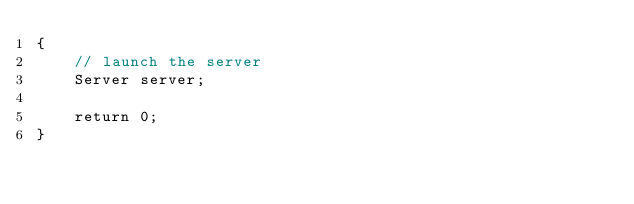<code> <loc_0><loc_0><loc_500><loc_500><_C++_>{
    // launch the server
    Server server;

    return 0;
}

</code> 